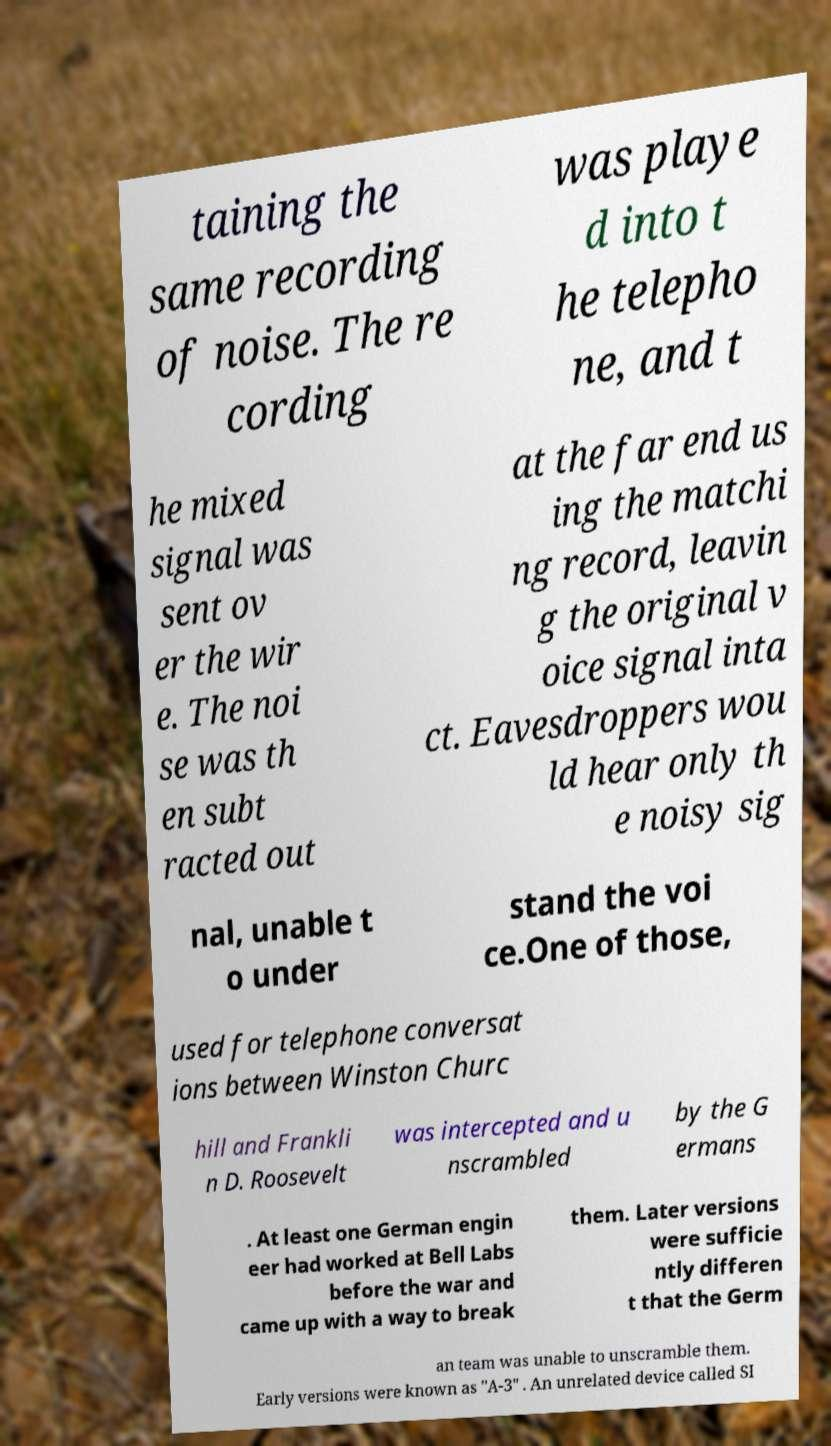There's text embedded in this image that I need extracted. Can you transcribe it verbatim? taining the same recording of noise. The re cording was playe d into t he telepho ne, and t he mixed signal was sent ov er the wir e. The noi se was th en subt racted out at the far end us ing the matchi ng record, leavin g the original v oice signal inta ct. Eavesdroppers wou ld hear only th e noisy sig nal, unable t o under stand the voi ce.One of those, used for telephone conversat ions between Winston Churc hill and Frankli n D. Roosevelt was intercepted and u nscrambled by the G ermans . At least one German engin eer had worked at Bell Labs before the war and came up with a way to break them. Later versions were sufficie ntly differen t that the Germ an team was unable to unscramble them. Early versions were known as "A-3" . An unrelated device called SI 